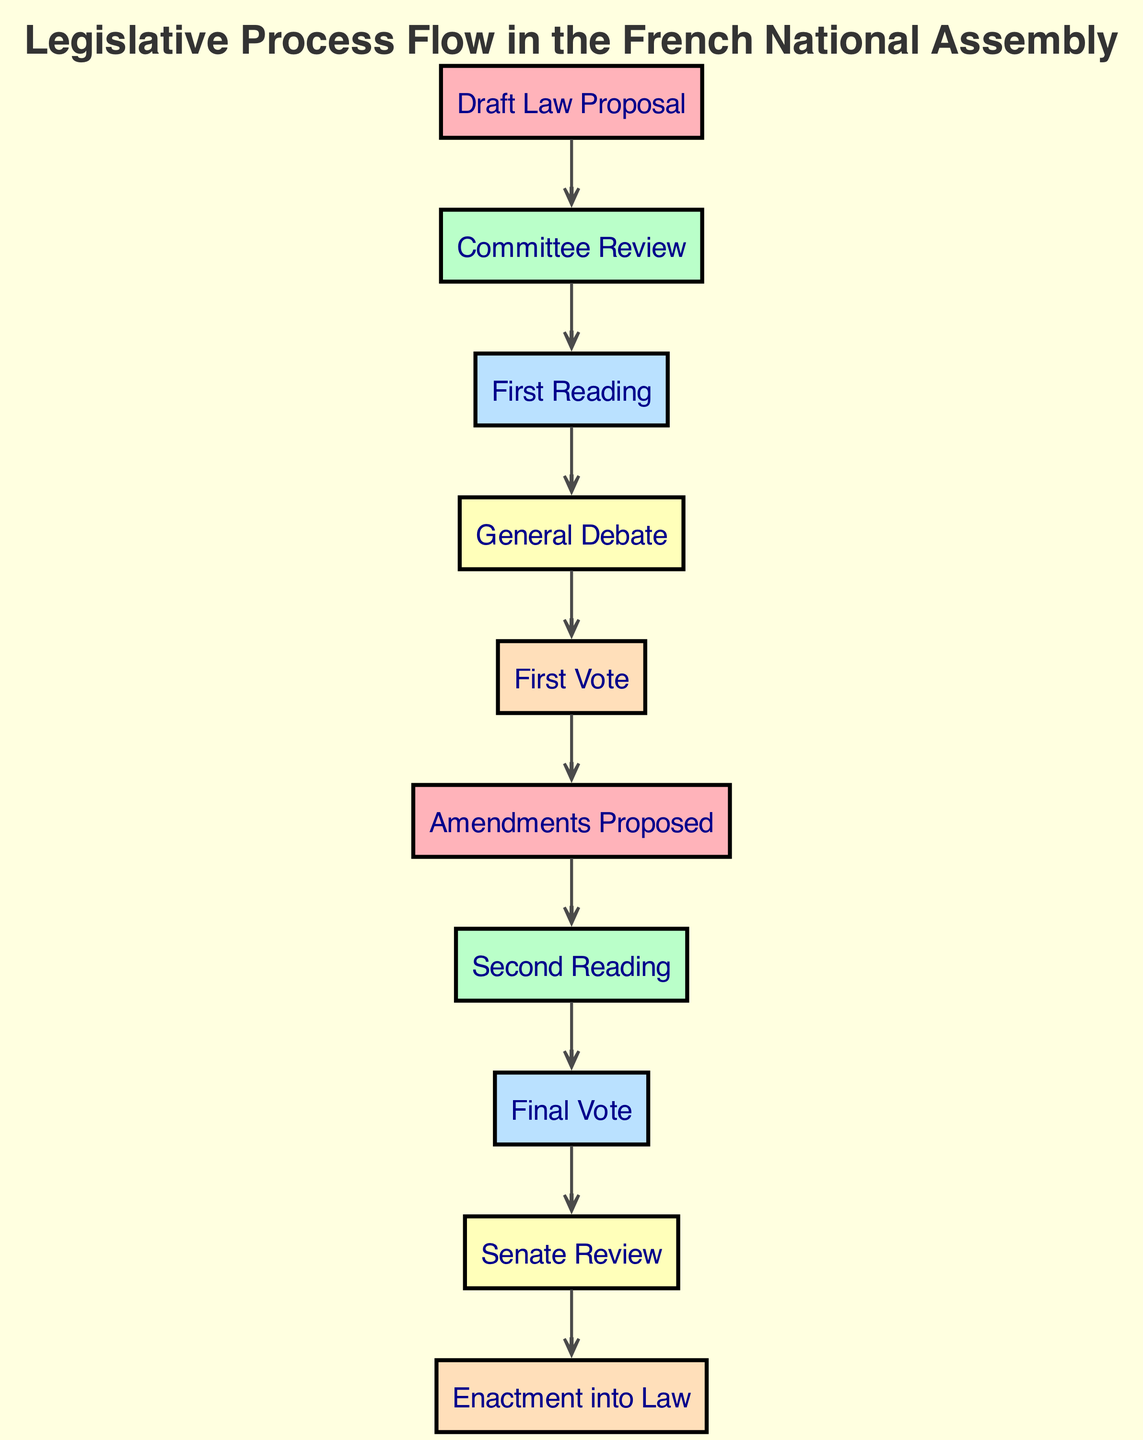What is the first step in the legislative process? The first step is the "Draft Law Proposal," which initiates the legislative process.
Answer: Draft Law Proposal How many nodes are present in the diagram? Counting the nodes listed, there are a total of 10 nodes in the diagram.
Answer: 10 What follows the "First Vote" in the legislative process? After the "First Vote," the next step is the "Amendments Proposed."
Answer: Amendments Proposed Which step is directly before "Final Vote"? The step directly before "Final Vote" is the "Second Reading."
Answer: Second Reading What is the final step in the legislative process? The last step in the legislative process as shown in the diagram is "Enactment into Law."
Answer: Enactment into Law If a draft law passes the "Committee Review," what is the next stage? The next stage after "Committee Review" is the "First Reading."
Answer: First Reading How many edges are there connecting the nodes? There are a total of 9 edges connecting the nodes in the diagram.
Answer: 9 What is the relationship between "Debate" and "Vote1"? The relationship is that "Vote1" follows directly after "Debate."
Answer: "Vote1" follows "Debate" What step follows the "Senate Review"? The step that follows "Senate Review" is "Enactment into Law."
Answer: Enactment into Law 